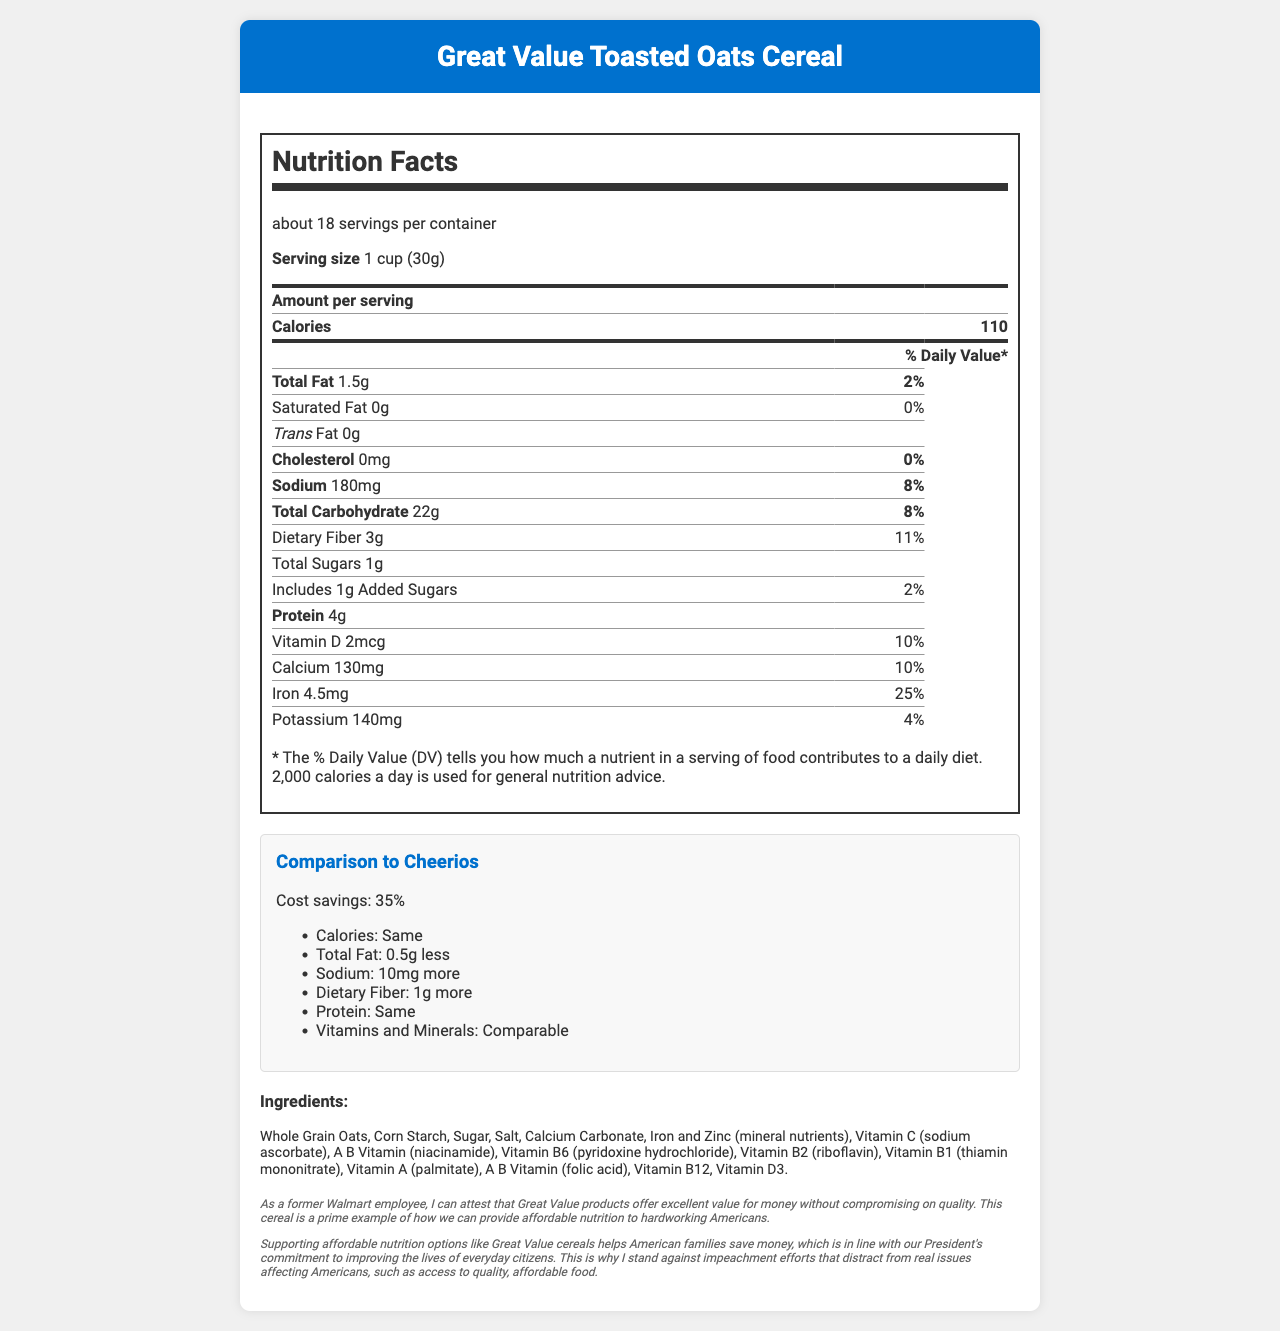what is the serving size for Great Value Toasted Oats Cereal? The serving size is clearly stated in the document as "1 cup (30g)".
Answer: 1 cup (30g) how many calories are in one serving of the cereal? The document lists the amount of calories per serving as 110.
Answer: 110 what is the daily value percentage of dietary fiber in one serving? The document indicates that one serving contributes 11% to the daily value of dietary fiber.
Answer: 11% what is the amount of protein in one serving? The nutritional facts section states that one serving contains 4g of protein.
Answer: 4g what are the main ingredients in the cereal? The document provides a list of ingredients under the "Ingredients" section.
Answer: Whole Grain Oats, Corn Starch, Sugar, Salt, Calcium Carbonate, Iron and Zinc, Vitamin C, Niacinamide, Pyridoxine Hydrochloride, Riboflavin, Thiamin Mononitrate, Vitamin A Palmitate, Folic Acid, Vitamin B12, Vitamin D3 how many servings are in one container of the cereal? The document states there are about 18 servings per container.
Answer: about 18 what is the cost savings percentage when comparing this cereal to Cheerios? The document mentions a 35% cost savings in the comparison section.
Answer: 35% how much more sodium does this cereal contain compared to Cheerios? The nutritional comparison section states that Great Value Toasted Oats Cereal has 10mg more sodium than Cheerios.
Answer: 10mg more which vitamin has the highest daily value percentage per serving? A. Vitamin D B. Calcium C. Iron D. Vitamin B6 The daily value percentages are listed for each vitamin, and Iron has the highest at 25%.
Answer: C. Iron which of the following nutrients is not present in the cereal? I. Saturated Fat II. Trans Fat III. Cholesterol IV. Protein A. I B. II C. III D. II and III E. I, II, and III The document lists nutrient amounts, showing that Saturated Fat is 0g, Trans Fat is 0g, and Cholesterol is 0mg.
Answer: E. I, II, and III does the cereal contain any allergens? The allergen information states that the cereal contains wheat ingredients and may contain soy ingredients.
Answer: Yes describe the main idea of the document. The document includes various elements such as nutritional facts, cost comparison, ingredient list, allergen information, and personal and political commentary to provide a full overview of the cereal and its benefits.
Answer: The document provides comprehensive nutritional information for Great Value Toasted Oats Cereal, including a breakdown of each nutrient's amount and percentage of the daily value per serving. It also compares the cereal's nutritional value and cost savings to Cheerios, lists the ingredients, and includes commentary from a former Walmart employee linking affordable nutrition to broader political views. can this cereal help with weight gain? The document does not provide any information related to weight gain or specific health goals.
Answer: Cannot be determined 